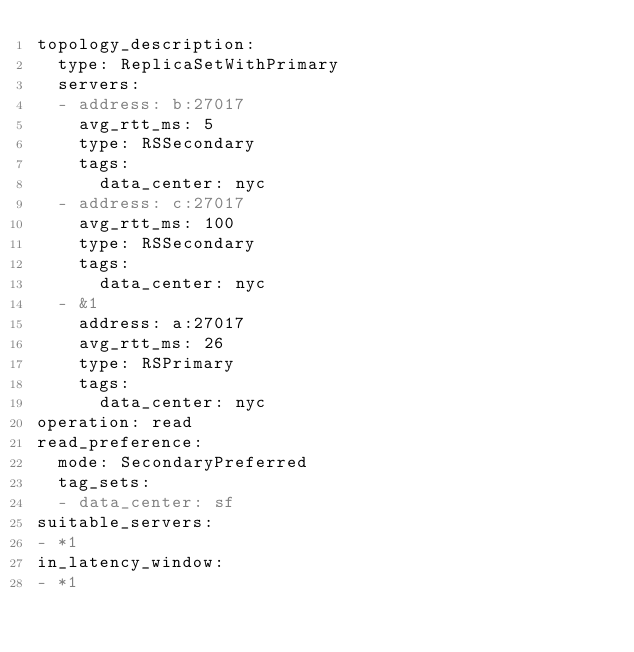Convert code to text. <code><loc_0><loc_0><loc_500><loc_500><_YAML_>topology_description:
  type: ReplicaSetWithPrimary
  servers:
  - address: b:27017
    avg_rtt_ms: 5
    type: RSSecondary
    tags:
      data_center: nyc
  - address: c:27017
    avg_rtt_ms: 100
    type: RSSecondary
    tags:
      data_center: nyc
  - &1
    address: a:27017
    avg_rtt_ms: 26
    type: RSPrimary
    tags:
      data_center: nyc
operation: read
read_preference:
  mode: SecondaryPreferred
  tag_sets:
  - data_center: sf
suitable_servers:
- *1
in_latency_window:
- *1
</code> 